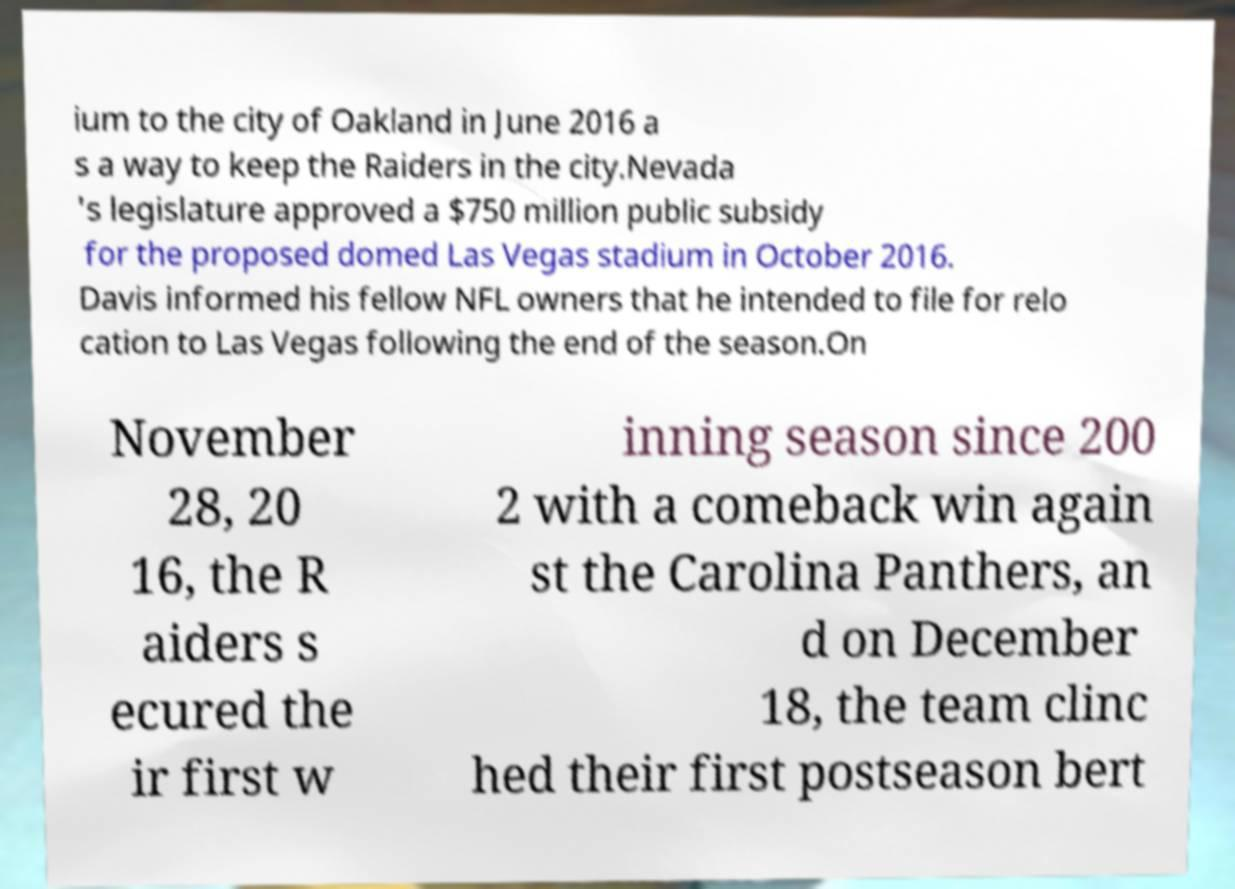I need the written content from this picture converted into text. Can you do that? ium to the city of Oakland in June 2016 a s a way to keep the Raiders in the city.Nevada 's legislature approved a $750 million public subsidy for the proposed domed Las Vegas stadium in October 2016. Davis informed his fellow NFL owners that he intended to file for relo cation to Las Vegas following the end of the season.On November 28, 20 16, the R aiders s ecured the ir first w inning season since 200 2 with a comeback win again st the Carolina Panthers, an d on December 18, the team clinc hed their first postseason bert 